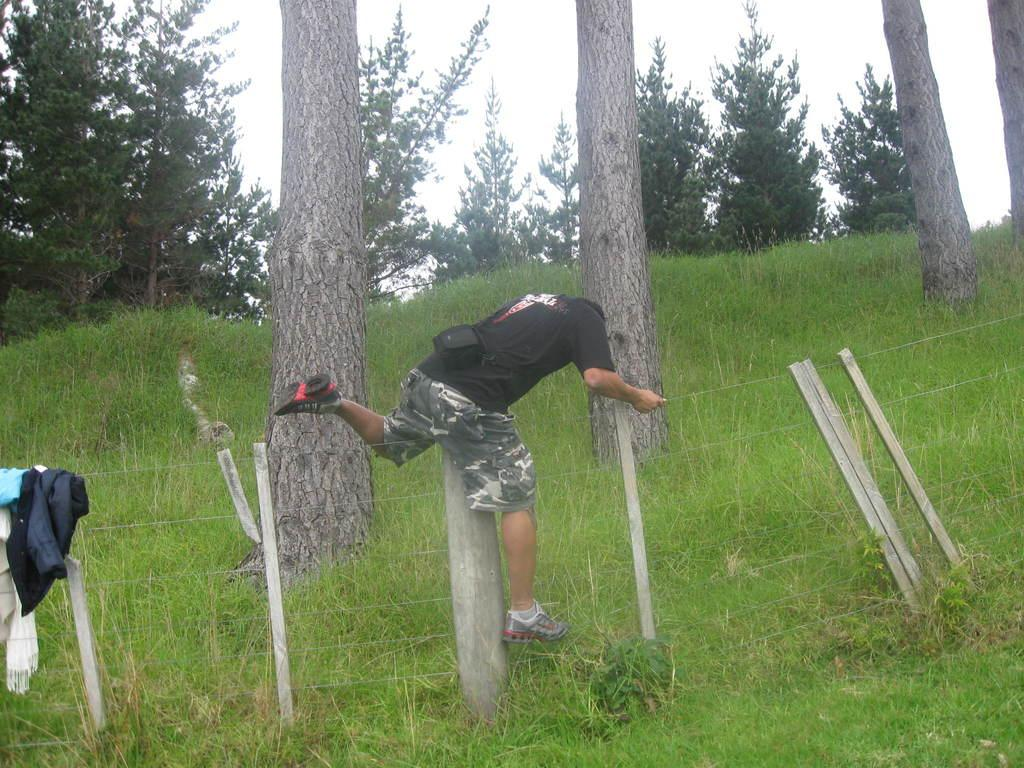What type of vegetation can be seen in the image? There are trees in the image. What is the man in the image doing? The man is crossing a fence in the image. What is the man carrying in the image? The man is wearing a bag. What else can be seen on the fence in the image? There are clothes on the fence in the image. What is visible on the ground in the image? Grass is visible on the ground in the image. What is the condition of the sky in the image? The sky is cloudy in the image. Where is the tent located in the image? There is no tent present in the image. What type of shop can be seen in the image? There is no shop present in the image. 